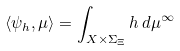<formula> <loc_0><loc_0><loc_500><loc_500>\langle \psi _ { h } , \mu \rangle = \int _ { X { \times } \Sigma _ { \Xi } } h \, d \mu ^ { \infty }</formula> 